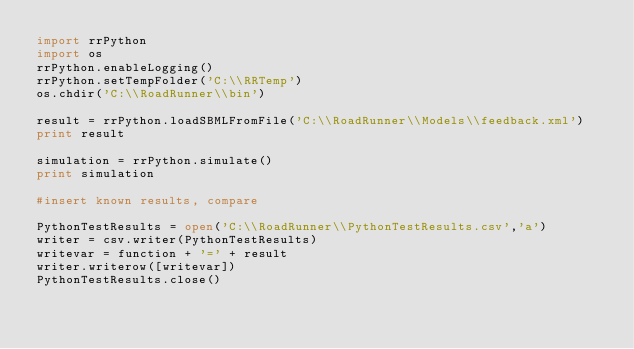Convert code to text. <code><loc_0><loc_0><loc_500><loc_500><_Python_>import rrPython
import os
rrPython.enableLogging()
rrPython.setTempFolder('C:\\RRTemp')
os.chdir('C:\\RoadRunner\\bin')

result = rrPython.loadSBMLFromFile('C:\\RoadRunner\\Models\\feedback.xml')
print result

simulation = rrPython.simulate()
print simulation

#insert known results, compare

PythonTestResults = open('C:\\RoadRunner\\PythonTestResults.csv','a')
writer = csv.writer(PythonTestResults)
writevar = function + '=' + result
writer.writerow([writevar])
PythonTestResults.close()</code> 